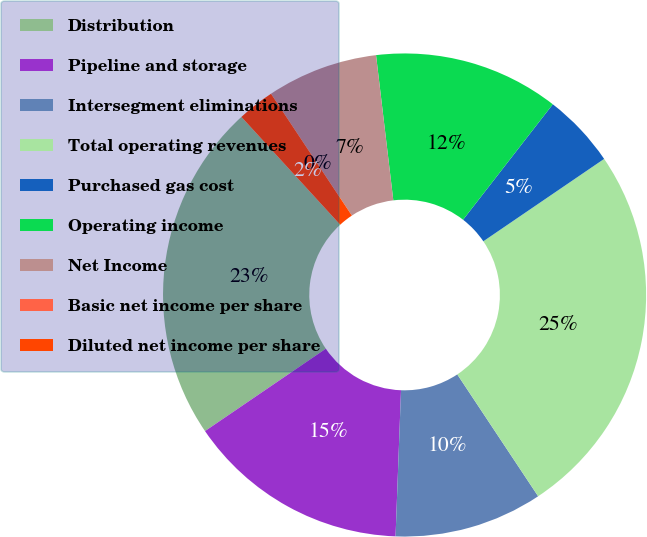<chart> <loc_0><loc_0><loc_500><loc_500><pie_chart><fcel>Distribution<fcel>Pipeline and storage<fcel>Intersegment eliminations<fcel>Total operating revenues<fcel>Purchased gas cost<fcel>Operating income<fcel>Net Income<fcel>Basic net income per share<fcel>Diluted net income per share<nl><fcel>22.72%<fcel>14.88%<fcel>9.92%<fcel>25.2%<fcel>4.96%<fcel>12.4%<fcel>7.44%<fcel>0.0%<fcel>2.48%<nl></chart> 